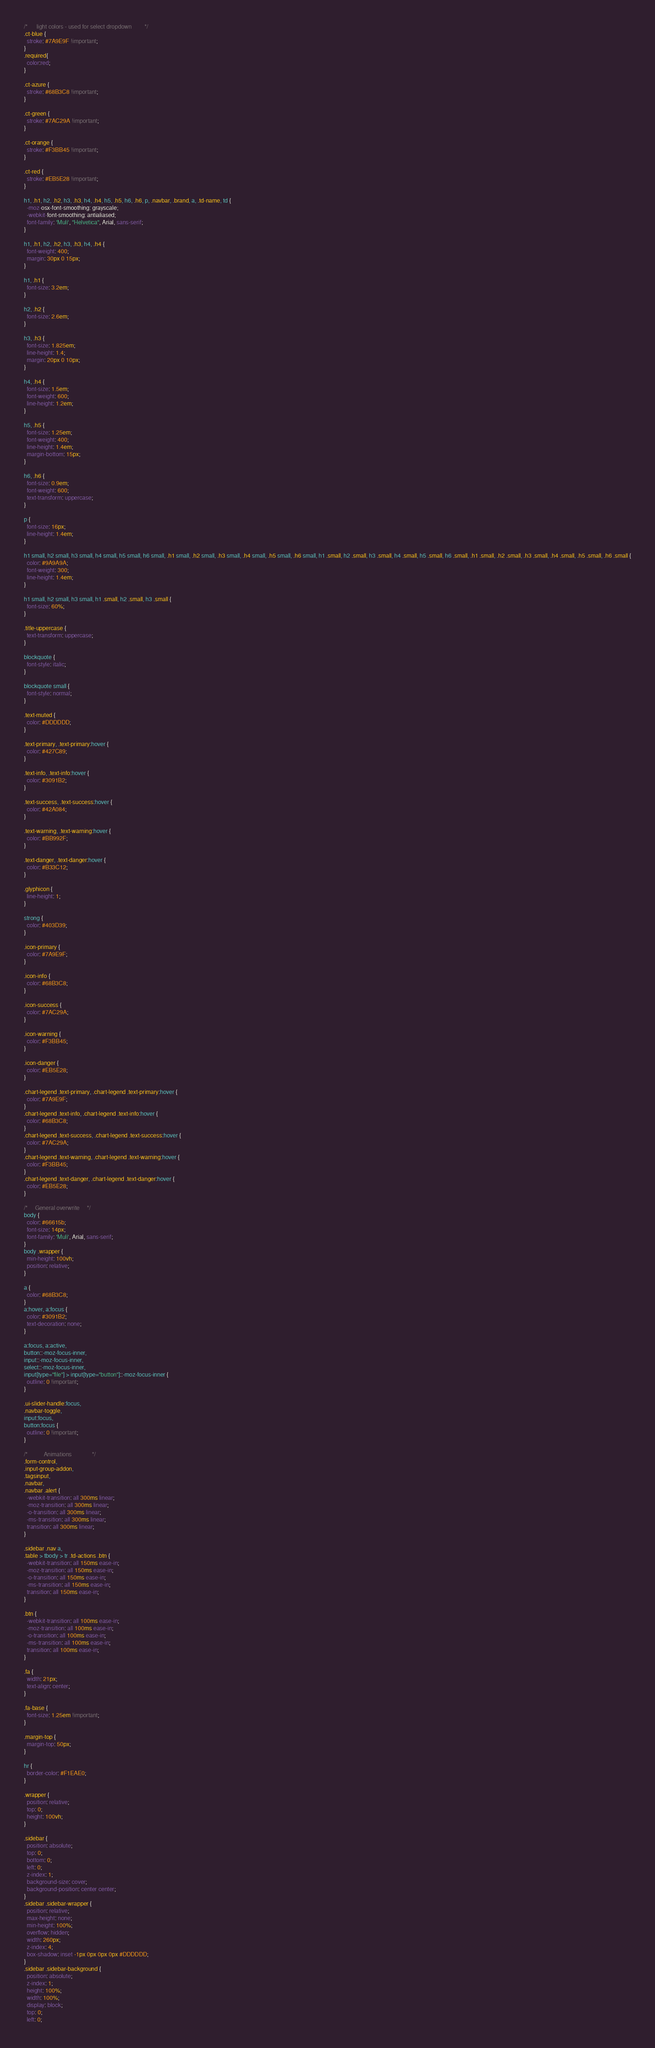Convert code to text. <code><loc_0><loc_0><loc_500><loc_500><_CSS_>/*      light colors - used for select dropdown         */
.ct-blue {
  stroke: #7A9E9F !important;
}
.required{
  color:red;
}

.ct-azure {
  stroke: #68B3C8 !important;
}

.ct-green {
  stroke: #7AC29A !important;
}

.ct-orange {
  stroke: #F3BB45 !important;
}

.ct-red {
  stroke: #EB5E28 !important;
}

h1, .h1, h2, .h2, h3, .h3, h4, .h4, h5, .h5, h6, .h6, p, .navbar, .brand, a, .td-name, td {
  -moz-osx-font-smoothing: grayscale;
  -webkit-font-smoothing: antialiased;
  font-family: 'Muli', "Helvetica", Arial, sans-serif;
}

h1, .h1, h2, .h2, h3, .h3, h4, .h4 {
  font-weight: 400;
  margin: 30px 0 15px;
}

h1, .h1 {
  font-size: 3.2em;
}

h2, .h2 {
  font-size: 2.6em;
}

h3, .h3 {
  font-size: 1.825em;
  line-height: 1.4;
  margin: 20px 0 10px;
}

h4, .h4 {
  font-size: 1.5em;
  font-weight: 600;
  line-height: 1.2em;
}

h5, .h5 {
  font-size: 1.25em;
  font-weight: 400;
  line-height: 1.4em;
  margin-bottom: 15px;
}

h6, .h6 {
  font-size: 0.9em;
  font-weight: 600;
  text-transform: uppercase;
}

p {
  font-size: 16px;
  line-height: 1.4em;
}

h1 small, h2 small, h3 small, h4 small, h5 small, h6 small, .h1 small, .h2 small, .h3 small, .h4 small, .h5 small, .h6 small, h1 .small, h2 .small, h3 .small, h4 .small, h5 .small, h6 .small, .h1 .small, .h2 .small, .h3 .small, .h4 .small, .h5 .small, .h6 .small {
  color: #9A9A9A;
  font-weight: 300;
  line-height: 1.4em;
}

h1 small, h2 small, h3 small, h1 .small, h2 .small, h3 .small {
  font-size: 60%;
}

.title-uppercase {
  text-transform: uppercase;
}

blockquote {
  font-style: italic;
}

blockquote small {
  font-style: normal;
}

.text-muted {
  color: #DDDDDD;
}

.text-primary, .text-primary:hover {
  color: #427C89;
}

.text-info, .text-info:hover {
  color: #3091B2;
}

.text-success, .text-success:hover {
  color: #42A084;
}

.text-warning, .text-warning:hover {
  color: #BB992F;
}

.text-danger, .text-danger:hover {
  color: #B33C12;
}

.glyphicon {
  line-height: 1;
}

strong {
  color: #403D39;
}

.icon-primary {
  color: #7A9E9F;
}

.icon-info {
  color: #68B3C8;
}

.icon-success {
  color: #7AC29A;
}

.icon-warning {
  color: #F3BB45;
}

.icon-danger {
  color: #EB5E28;
}

.chart-legend .text-primary, .chart-legend .text-primary:hover {
  color: #7A9E9F;
}
.chart-legend .text-info, .chart-legend .text-info:hover {
  color: #68B3C8;
}
.chart-legend .text-success, .chart-legend .text-success:hover {
  color: #7AC29A;
}
.chart-legend .text-warning, .chart-legend .text-warning:hover {
  color: #F3BB45;
}
.chart-legend .text-danger, .chart-legend .text-danger:hover {
  color: #EB5E28;
}

/*     General overwrite     */
body {
  color: #66615b;
  font-size: 14px;
  font-family: 'Muli', Arial, sans-serif;
}
body .wrapper {
  min-height: 100vh;
  position: relative;
}

a {
  color: #68B3C8;
}
a:hover, a:focus {
  color: #3091B2;
  text-decoration: none;
}

a:focus, a:active,
button::-moz-focus-inner,
input::-moz-focus-inner,
select::-moz-focus-inner,
input[type="file"] > input[type="button"]::-moz-focus-inner {
  outline: 0 !important;
}

.ui-slider-handle:focus,
.navbar-toggle,
input:focus,
button:focus {
  outline: 0 !important;
}

/*           Animations              */
.form-control,
.input-group-addon,
.tagsinput,
.navbar,
.navbar .alert {
  -webkit-transition: all 300ms linear;
  -moz-transition: all 300ms linear;
  -o-transition: all 300ms linear;
  -ms-transition: all 300ms linear;
  transition: all 300ms linear;
}

.sidebar .nav a,
.table > tbody > tr .td-actions .btn {
  -webkit-transition: all 150ms ease-in;
  -moz-transition: all 150ms ease-in;
  -o-transition: all 150ms ease-in;
  -ms-transition: all 150ms ease-in;
  transition: all 150ms ease-in;
}

.btn {
  -webkit-transition: all 100ms ease-in;
  -moz-transition: all 100ms ease-in;
  -o-transition: all 100ms ease-in;
  -ms-transition: all 100ms ease-in;
  transition: all 100ms ease-in;
}

.fa {
  width: 21px;
  text-align: center;
}

.fa-base {
  font-size: 1.25em !important;
}

.margin-top {
  margin-top: 50px;
}

hr {
  border-color: #F1EAE0;
}

.wrapper {
  position: relative;
  top: 0;
  height: 100vh;
}

.sidebar {
  position: absolute;
  top: 0;
  bottom: 0;
  left: 0;
  z-index: 1;
  background-size: cover;
  background-position: center center;
}
.sidebar .sidebar-wrapper {
  position: relative;
  max-height: none;
  min-height: 100%;
  overflow: hidden;
  width: 260px;
  z-index: 4;
  box-shadow: inset -1px 0px 0px 0px #DDDDDD;
}
.sidebar .sidebar-background {
  position: absolute;
  z-index: 1;
  height: 100%;
  width: 100%;
  display: block;
  top: 0;
  left: 0;</code> 